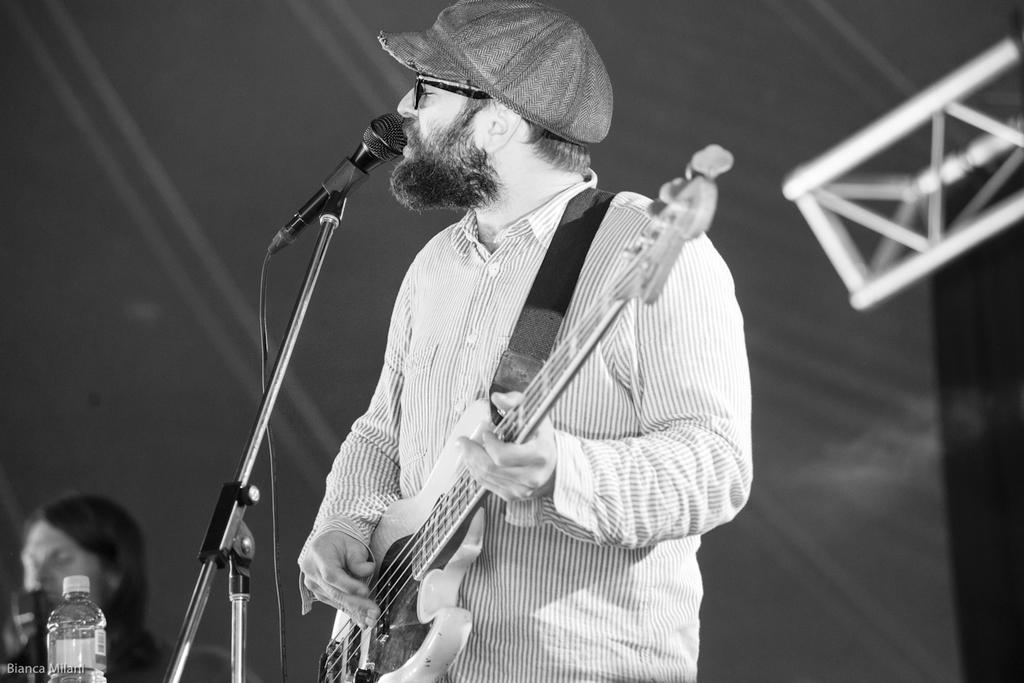What is the person in the image doing? The person is playing a guitar. What is the person wearing in the image? The person is wearing a white shirt. What object is in front of the person? There is a microphone in front of the person. What can be seen at the left side of the image? There is a bottle at the left side of the image. How many pets are participating in the competition in the image? There is no competition or pets present in the image. 